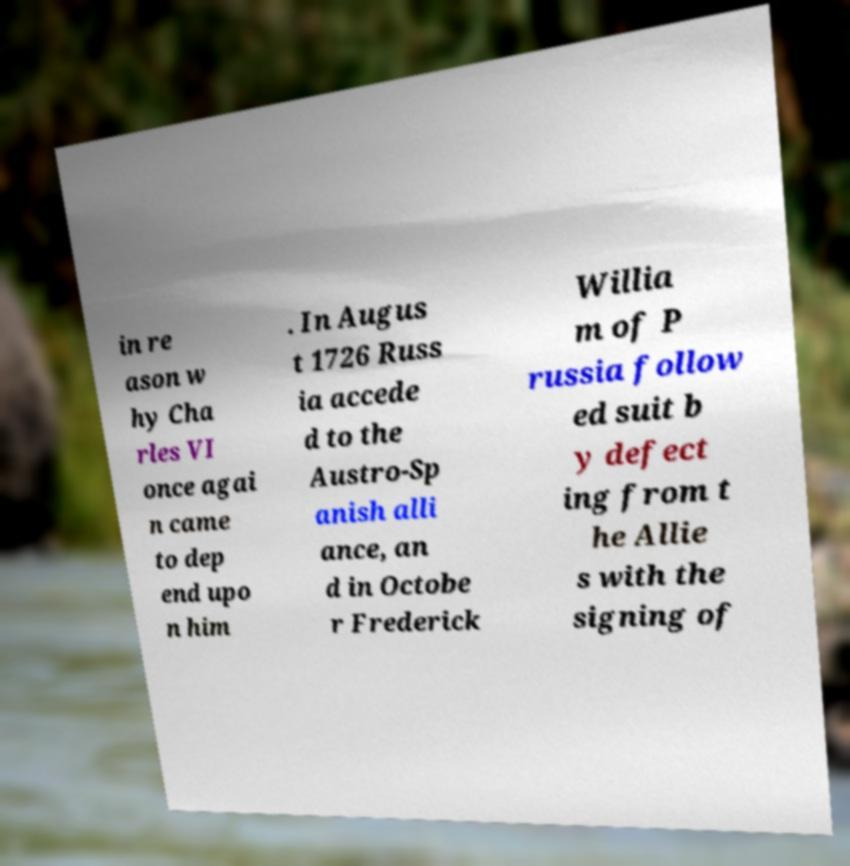There's text embedded in this image that I need extracted. Can you transcribe it verbatim? in re ason w hy Cha rles VI once agai n came to dep end upo n him . In Augus t 1726 Russ ia accede d to the Austro-Sp anish alli ance, an d in Octobe r Frederick Willia m of P russia follow ed suit b y defect ing from t he Allie s with the signing of 